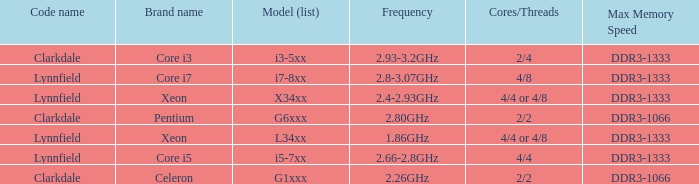What is the maximum memory speed for frequencies between 2.93-3.2ghz? DDR3-1333. 